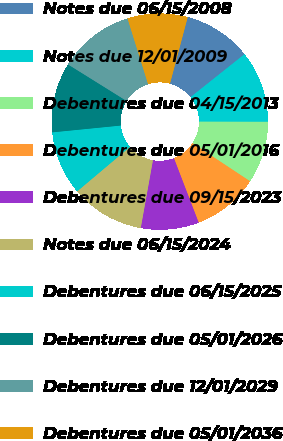<chart> <loc_0><loc_0><loc_500><loc_500><pie_chart><fcel>Notes due 06/15/2008<fcel>Notes due 12/01/2009<fcel>Debentures due 04/15/2013<fcel>Debentures due 05/01/2016<fcel>Debentures due 09/15/2023<fcel>Notes due 06/15/2024<fcel>Debentures due 06/15/2025<fcel>Debentures due 05/01/2026<fcel>Debentures due 12/01/2029<fcel>Debentures due 05/01/2036<nl><fcel>10.16%<fcel>10.73%<fcel>9.27%<fcel>9.86%<fcel>8.67%<fcel>11.02%<fcel>9.57%<fcel>10.45%<fcel>11.3%<fcel>8.97%<nl></chart> 